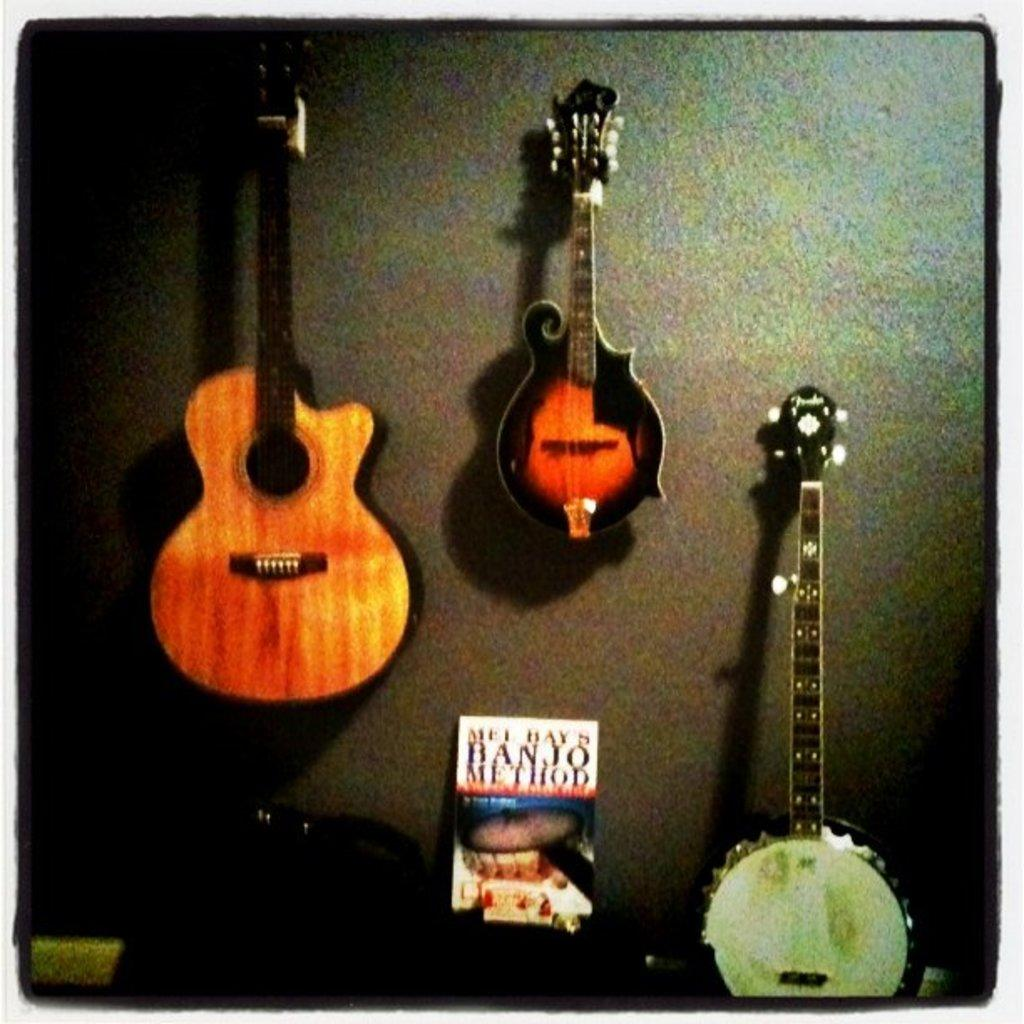What type of objects are present in the image? There are musical instruments in the image. Can you identify any specific musical instrument in the image? Yes, there is a guitar in the image. Are there any other objects present in the image besides musical instruments? Yes, there is a book in the image. What type of argument is taking place between the guitar and the book in the image? There is no argument taking place between the guitar and the book in the image, as they are inanimate objects and cannot engage in arguments. 